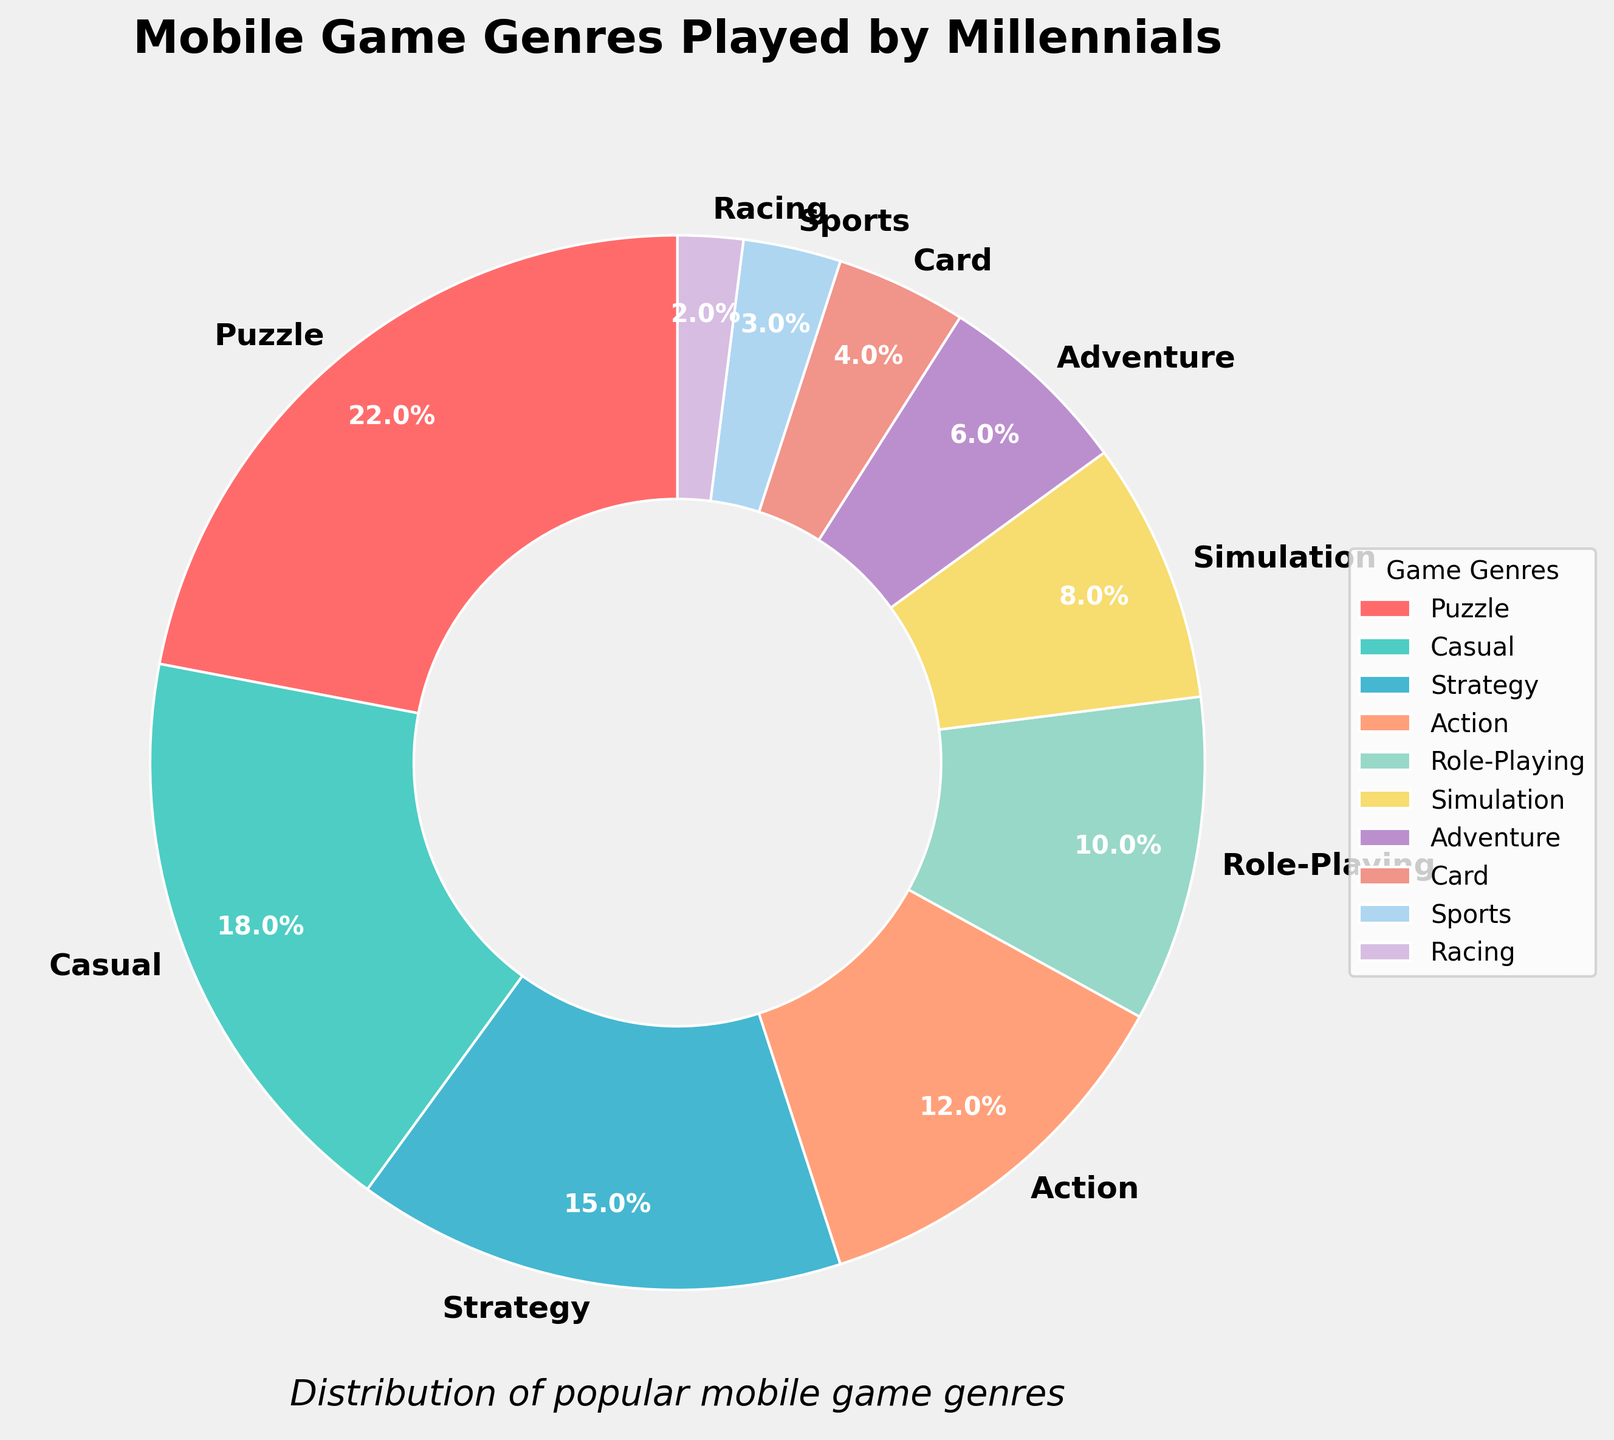What is the most popular mobile game genre among millennials? By observing the pie chart, the puzzle genre occupies the largest portion, which is identified by the label on the chart.
Answer: Puzzle Which genre has a higher percentage: Action or Strategy? By comparing the labeled percentages for Action and Strategy in the pie chart, we can see that Action is 12% and Strategy is 15%.
Answer: Strategy What is the total percentage for Puzzle and Casual genres combined? The percentages for Puzzle and Casual are 22% and 18%, respectively. Adding them yields 22 + 18 = 40.
Answer: 40% How much larger is the percentage of Puzzle games compared to Sports games? The percent of Puzzle games is 22% and for Sports games is 3%. The difference is 22 - 3 = 19.
Answer: 19% Is Role-Playing games' percentage more than double that of Racing games? The percentage for Role-Playing is 10% and Racing is 2%. Doubling the Racing percentage gives 2 * 2 = 4%. Since 10% is greater than 4%, Role-Playing is more than double Racing.
Answer: Yes Which genre represented by a grey-ish hue has the lowest percentage? By analyzing the colors in the chart and corresponding genres, Racing (2%) represented by a grey-ish hue has the lowest percentage.
Answer: Racing What is the second least popular mobile game genre among millennials? By inspecting the pie chart for the second smallest segment, Sports at 3% is the second least popular genre.
Answer: Sports How does the average percentage of Casual, Strategy, and Action genres compare to the percentage of Puzzle games? Here's the calculation: Average percentage of Casual, Strategy, and Action = (18 + 15 + 12) / 3 = 45 / 3 = 15%. The percentage of Puzzle games is 22%. Comparing them shows 15% < 22%.
Answer: Less than Puzzle Which has a bigger share, Adventure or Simulation games? Adventure games account for 6%, while Simulation games account for 8%. Comparing these percentages shows Simulation is larger.
Answer: Simulation How many genres have a percentage higher than 10%? By examining the chart, the genres with higher percentages than 10% are Puzzle (22%), Casual (18%), and Strategy (15%), totaling three genres.
Answer: 3 